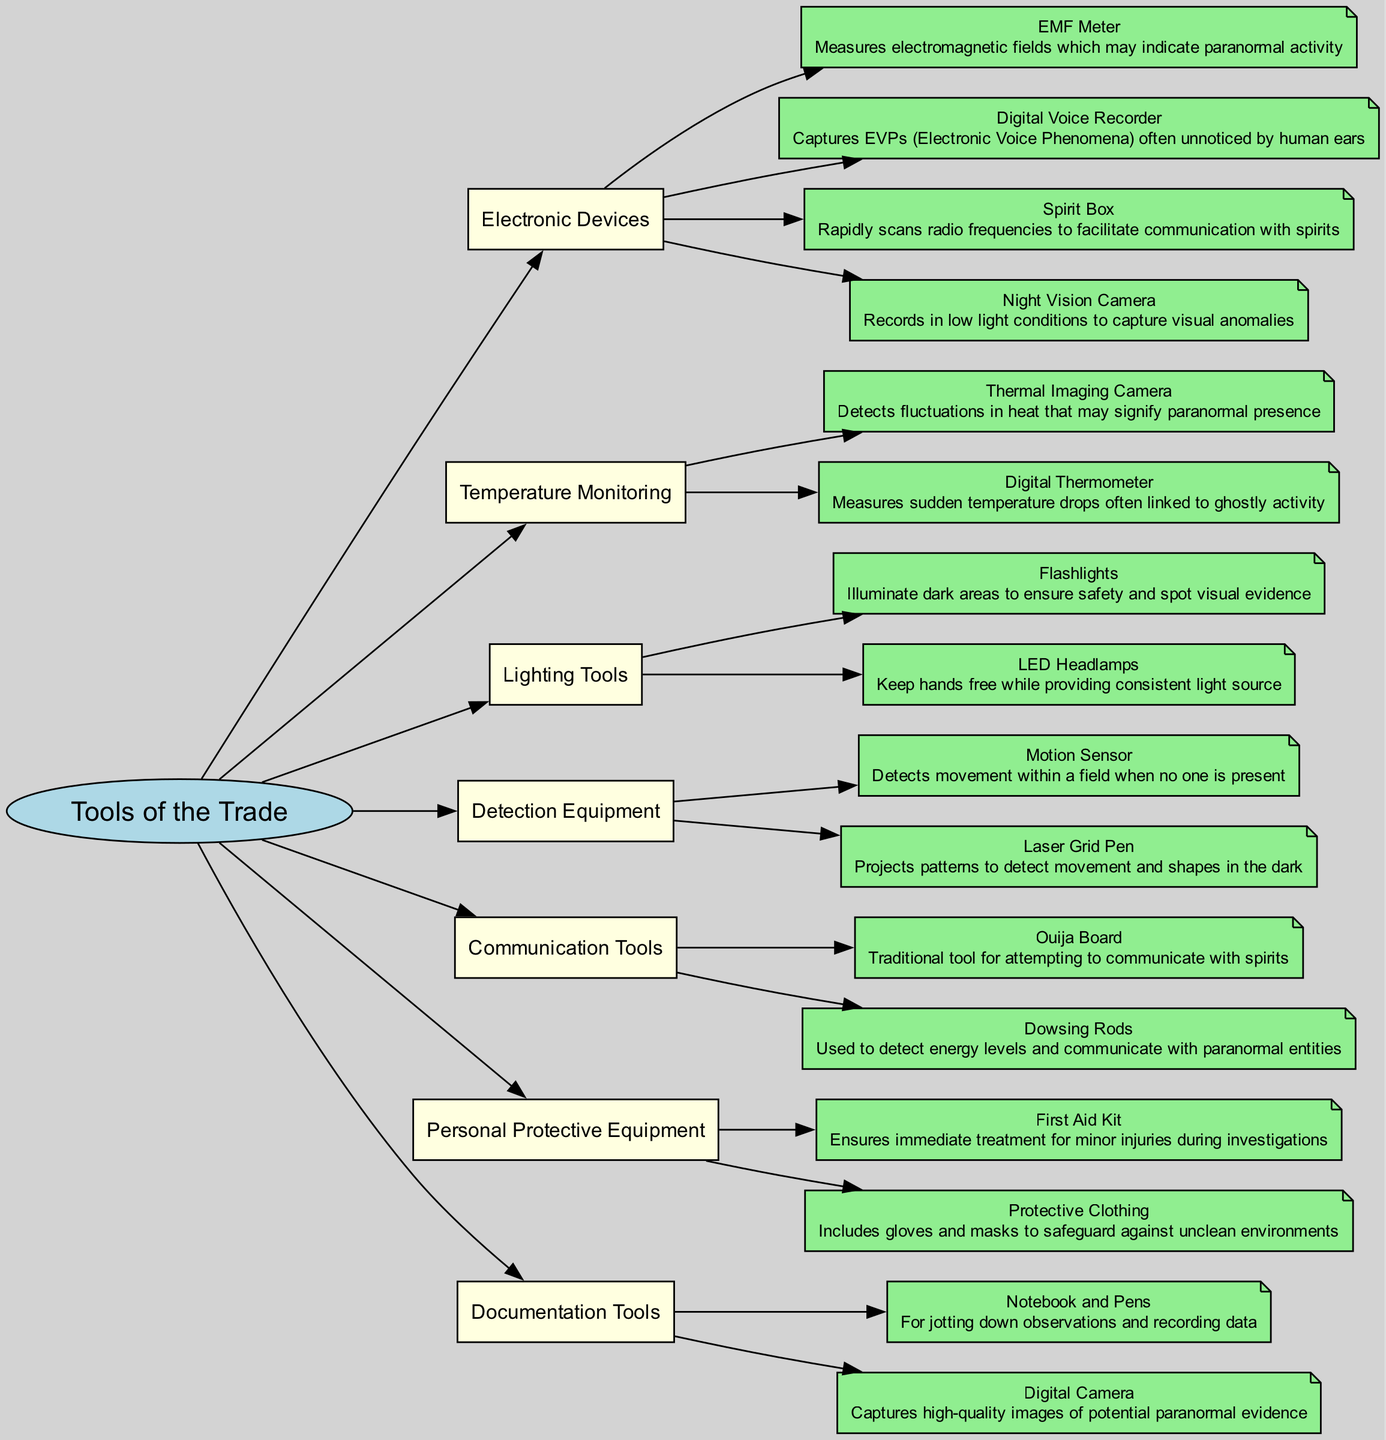What is the primary focus of this concept map? The concept map is centered around the tools used for paranormal investigations. It categorizes various equipment essential for conducting these investigations, showcasing their specific uses and functions.
Answer: Tools of the Trade How many main categories are present in this diagram? By examining the first level, we see there are six main categories listed: Electronic Devices, Temperature Monitoring, Lighting Tools, Detection Equipment, Communication Tools, and Personal Protective Equipment. Counting these gives us the total number of categories.
Answer: 6 Which tool is associated with capturing Electronic Voice Phenomena? In the Electronic Devices category, the Digital Voice Recorder is specifically mentioned for its ability to capture EVPs, which are sounds that some believe to be voices from spirits. Identifying this tool from the description allows us to answer.
Answer: Digital Voice Recorder What tool detects fluctuations in heat? The Thermal Imaging Camera, listed under the Temperature Monitoring category, is designed to detect heat changes that may indicate paranormal presence. By pinpointing the related tool, we can determine the answer.
Answer: Thermal Imaging Camera How does a Laser Grid Pen function in paranormal investigations? The description states that a Laser Grid Pen projects patterns to identify movement and shapes in darkness. To answer this, we refer to the description attached to the tool in the Detection Equipment category.
Answer: Projects patterns What relationship exists between Ouija Board and Communication Tools? The Ouija Board is directly categorized under Communication Tools, indicating its function as a traditional method for attempting to communicate with spirits. Recognizing this relation helps us answer the question.
Answer: Direct relationship How many tools are listed under Personal Protective Equipment? Looking at the Personal Protective Equipment category, we see two tools: First Aid Kit and Protective Clothing. Counting these gives us the total number of tools under this category.
Answer: 2 Why might a digital camera be important during investigations? The diagram indicates that a Digital Camera is a Documentation Tool that captures high-quality images of potential paranormal evidence. Understanding this significance highlights its role in research findings.
Answer: Captures evidence What common purpose do Flashlights and LED Headlamps serve? Both tools, listed under Lighting Tools, are designed to illuminate dark areas, ensuring safety while also allowing investigators to spot visual evidence. This commonality clarifies their shared purpose in investigations.
Answer: Illuminate dark areas 